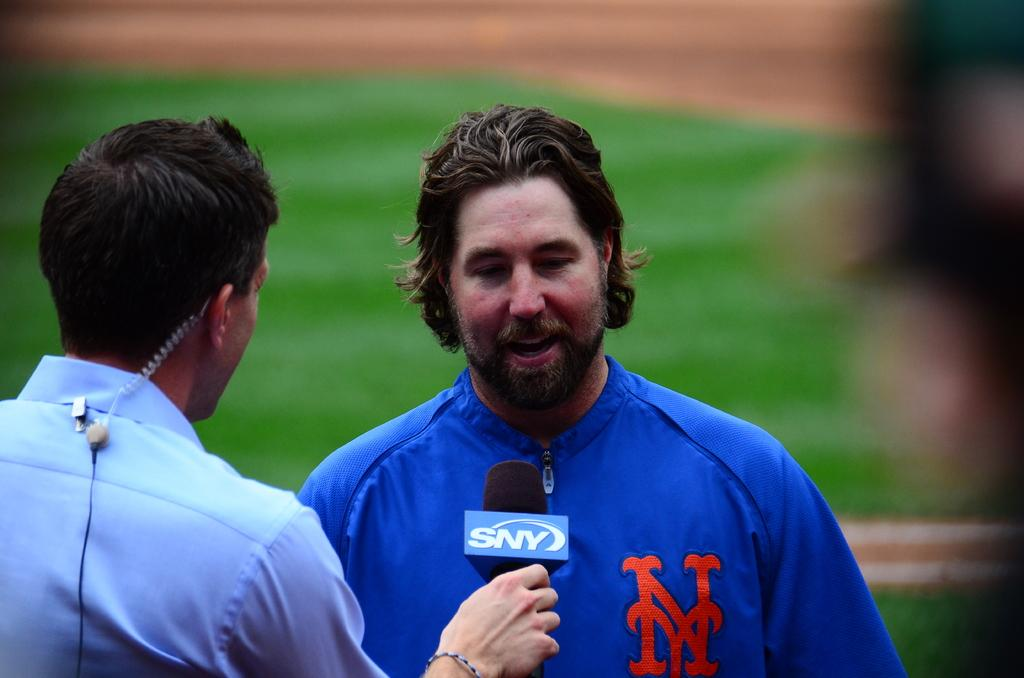<image>
Give a short and clear explanation of the subsequent image. A player in a uniform talking into a mic that has SNY on it 